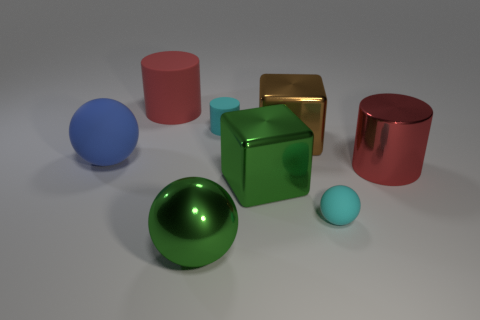Are there any cubes in the image, and if so, what are their characteristics? Indeed, there is one cube in the image. It has a shiny gold surface and appears to be perfectly symmetrical and solid. 